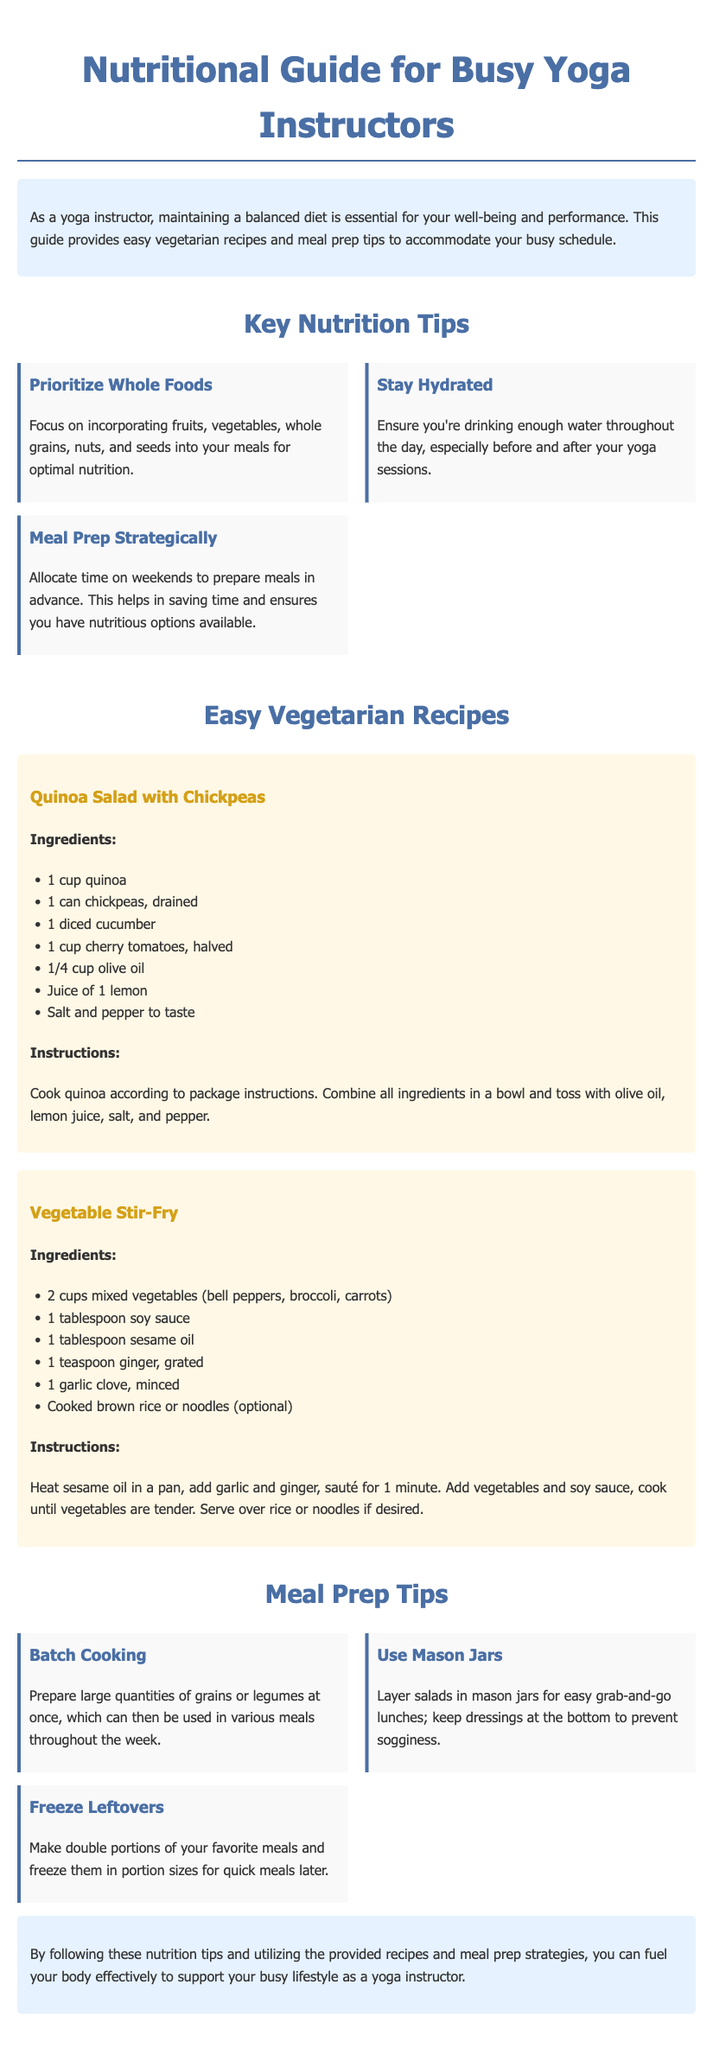what is the title of the guide? The title of the guide is the main heading of the document, which introduces the content for busy yoga instructors.
Answer: Nutritional Guide for Busy Yoga Instructors how many easy vegetarian recipes are provided? The section on recipes includes two easy vegetarian recipes listed in the document.
Answer: 2 name one key nutrition tip mentioned in the document. The key nutrition tips are highlighted as important aspects of a balanced diet for yoga instructors.
Answer: Prioritize Whole Foods what ingredient is used in the Quinoa Salad? The recipe for Quinoa Salad specifies various ingredients that contribute to the dish's flavor and nutrition.
Answer: Chickpeas what is recommended for meal prep on weekends? The meal prep section offers a strategic approach to preparing meals that will save time throughout the week.
Answer: Allocate time on weekends how should salads be stored for easy lunches? A tip in the document provides a convenient way to prepare salads for quick access during busy days.
Answer: Use Mason Jars what type of oil is used in the Vegetable Stir-Fry? The recipe provides specific cooking ingredients that enhance the dish's flavor profile.
Answer: Sesame oil what should be done with leftovers? The document emphasizes the importance of managing food waste and saving time in meal preparation with leftovers.
Answer: Freeze Leftovers 